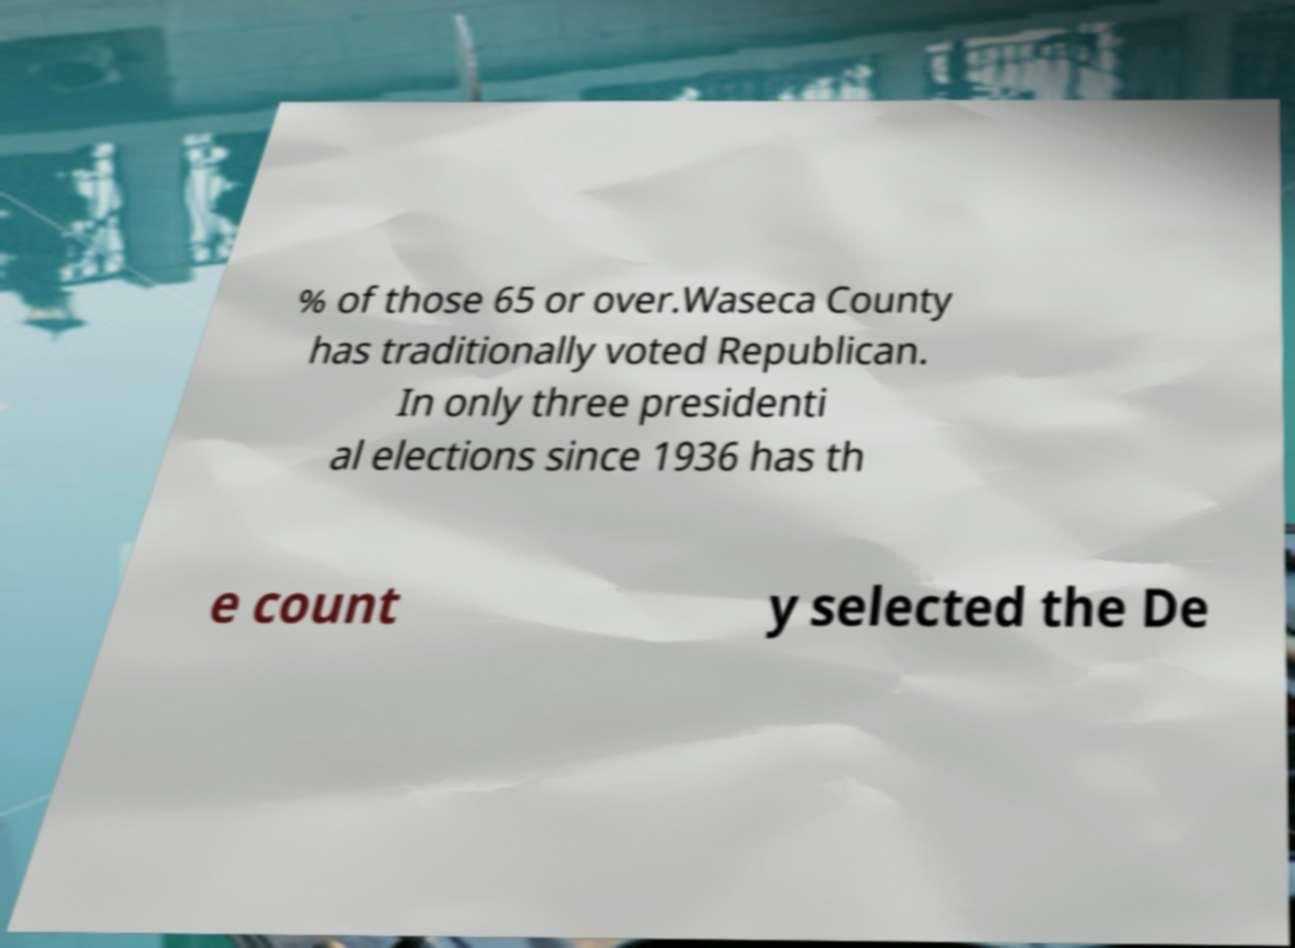Can you accurately transcribe the text from the provided image for me? % of those 65 or over.Waseca County has traditionally voted Republican. In only three presidenti al elections since 1936 has th e count y selected the De 